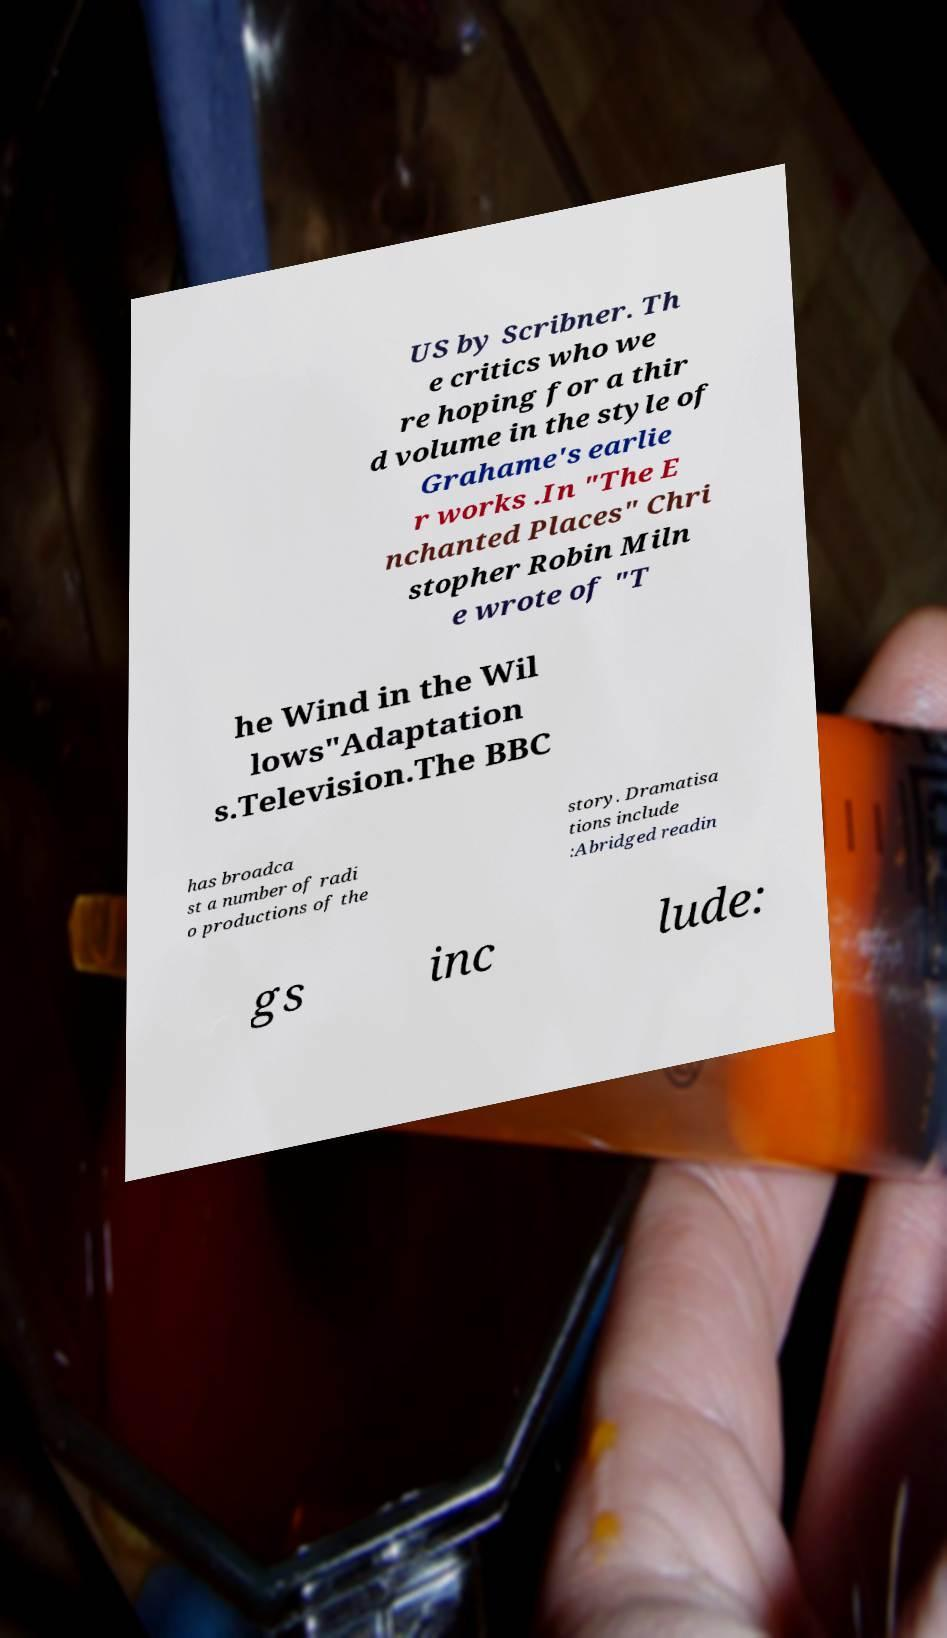I need the written content from this picture converted into text. Can you do that? US by Scribner. Th e critics who we re hoping for a thir d volume in the style of Grahame's earlie r works .In "The E nchanted Places" Chri stopher Robin Miln e wrote of "T he Wind in the Wil lows"Adaptation s.Television.The BBC has broadca st a number of radi o productions of the story. Dramatisa tions include :Abridged readin gs inc lude: 